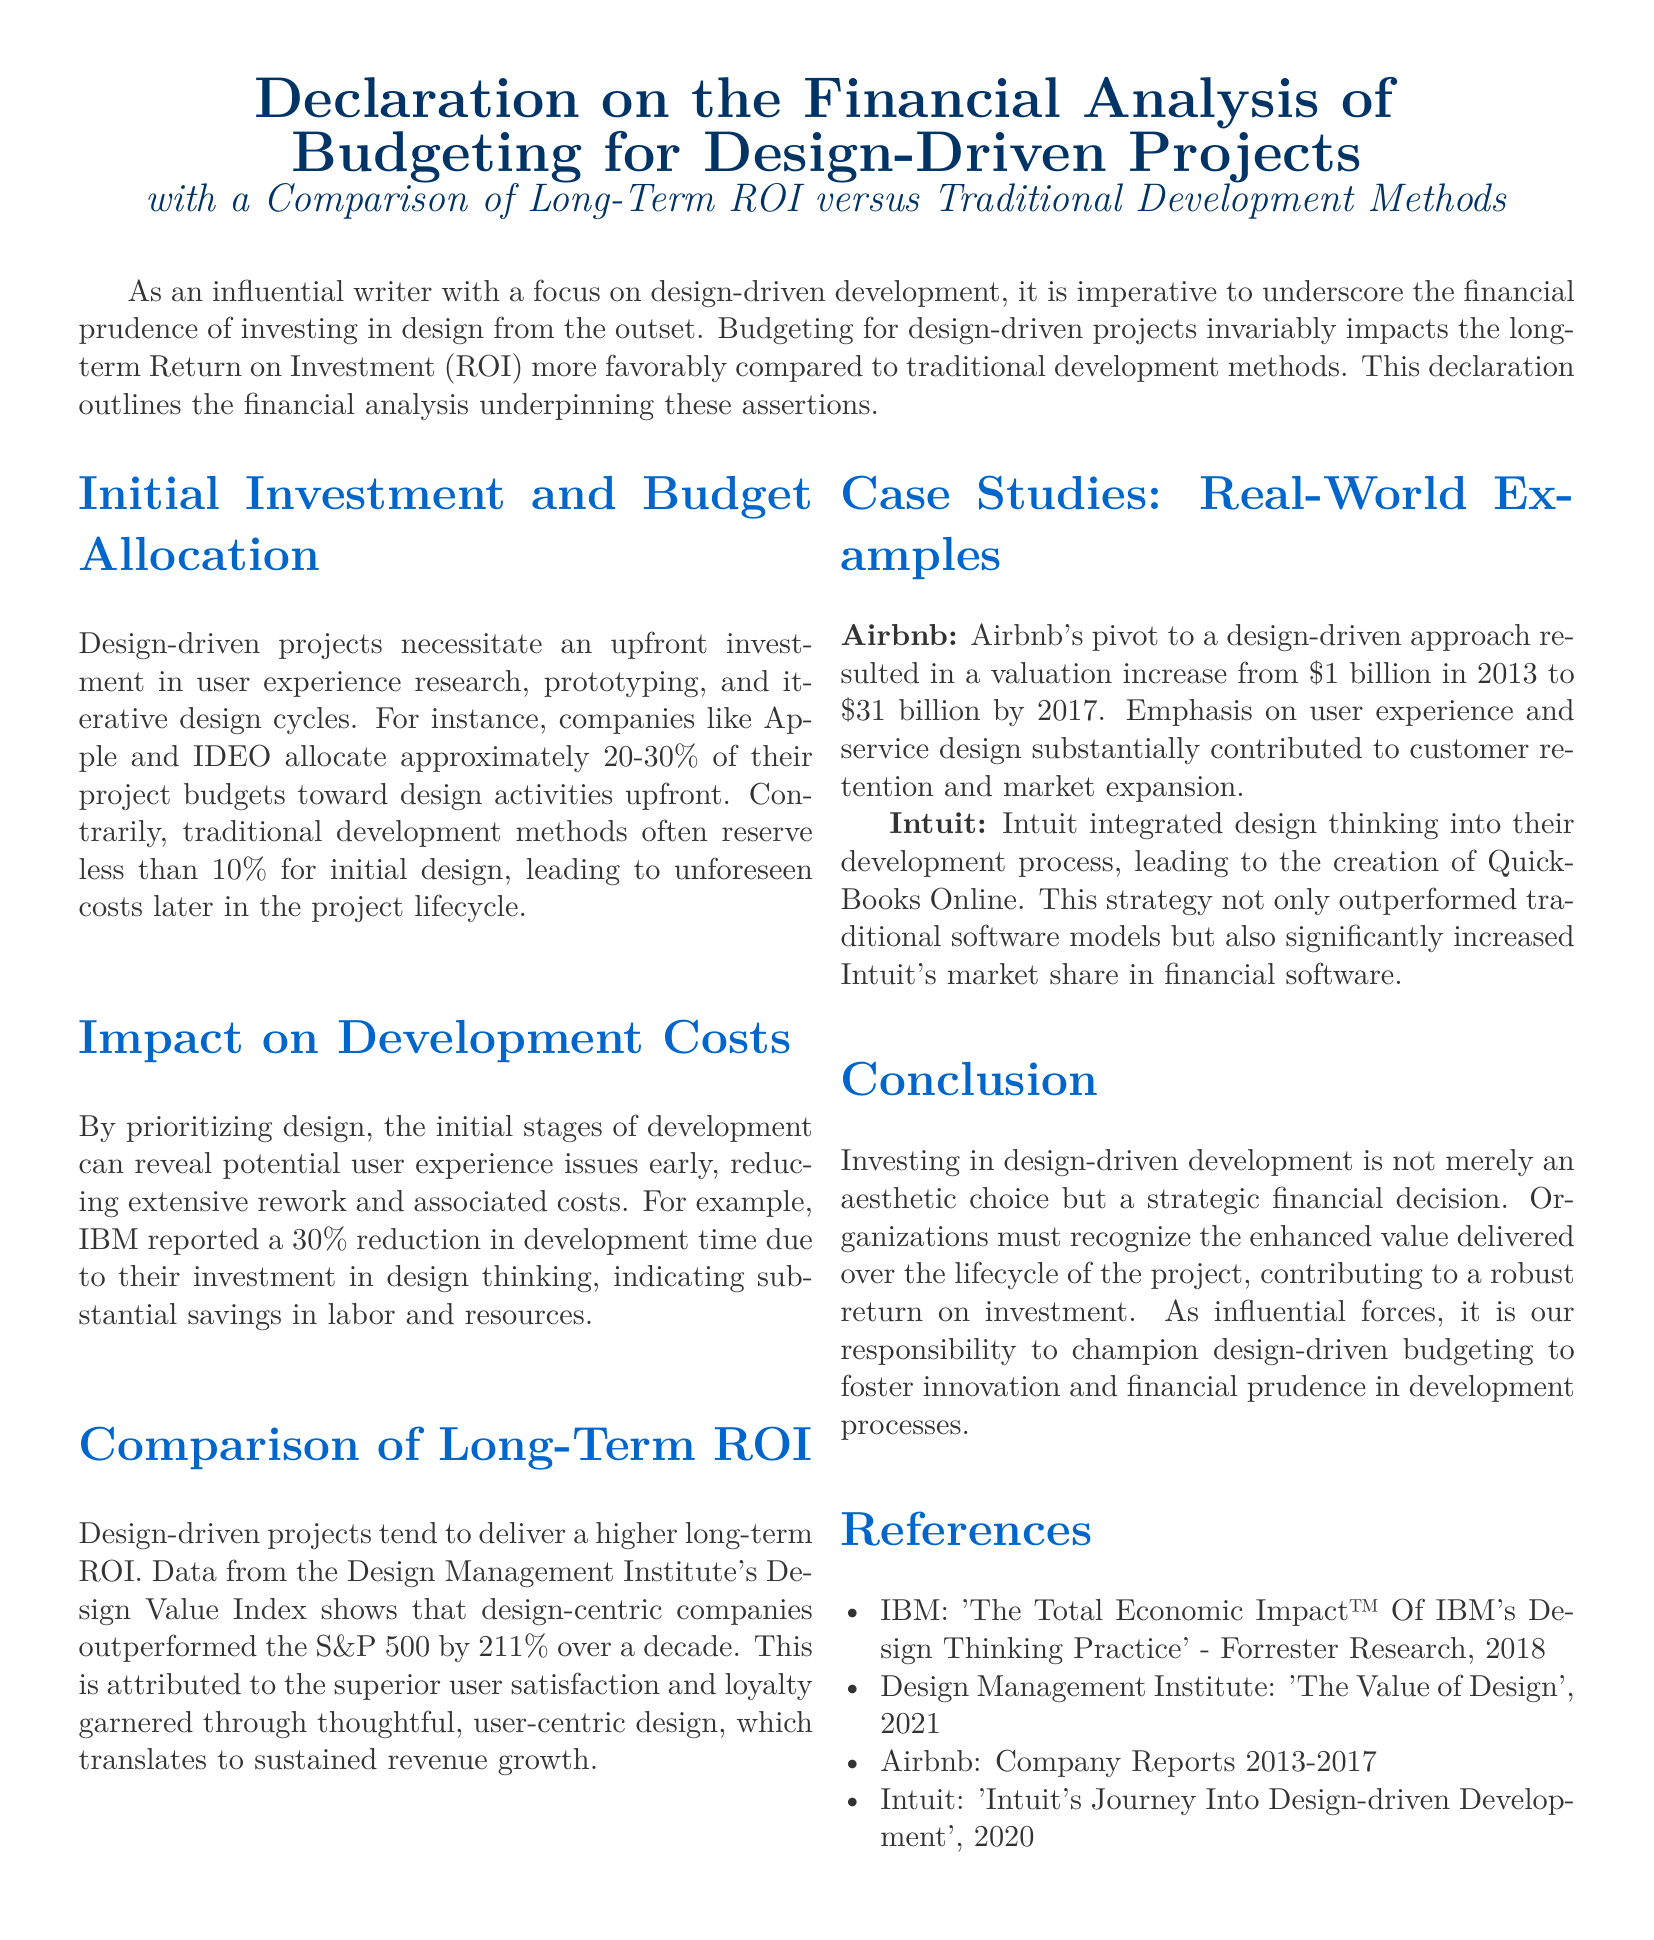What is the percentage of project budgets that companies like Apple and IDEO allocate to design activities? The document states that companies like Apple and IDEO allocate approximately 20-30% of their project budgets toward design activities upfront.
Answer: 20-30% What reduction in development time did IBM report due to investment in design thinking? The document mentions that IBM reported a 30% reduction in development time due to their investment in design thinking.
Answer: 30% Which index shows that design-centric companies outperformed the S&P 500? The Design Management Institute's Design Value Index is referenced in the document as showing that design-centric companies outperformed the S&P 500.
Answer: Design Value Index What was Airbnb's valuation in 2013? According to the document, Airbnb's valuation was $1 billion in 2013.
Answer: $1 billion What significant increase did Airbnb's design-driven approach result in by 2017? The document states that Airbnb's valuation increased to $31 billion by 2017 due to their design-driven approach.
Answer: $31 billion Which software did Intuit create by integrating design thinking into their development process? The document indicates that Intuit created QuickBooks Online by integrating design thinking into their development process.
Answer: QuickBooks Online What is the focus of the declaration presented in this document? The focus of the declaration is on the financial analysis of budgeting for design-driven projects.
Answer: Financial analysis of budgeting for design-driven projects What should organizations recognize according to the conclusion of the document? The conclusion states that organizations must recognize the enhanced value delivered over the lifecycle of the project.
Answer: Enhanced value delivered over the lifecycle of the project 